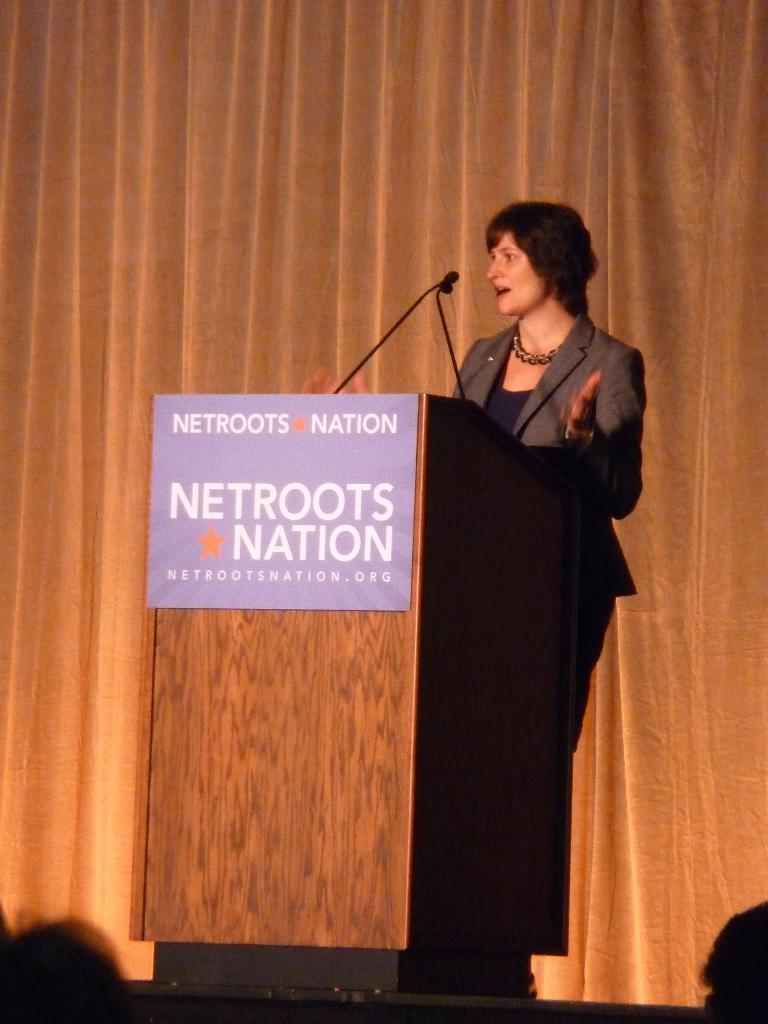<image>
Provide a brief description of the given image. A woman speaks at a lectern on a stage for a netroots nation event. 